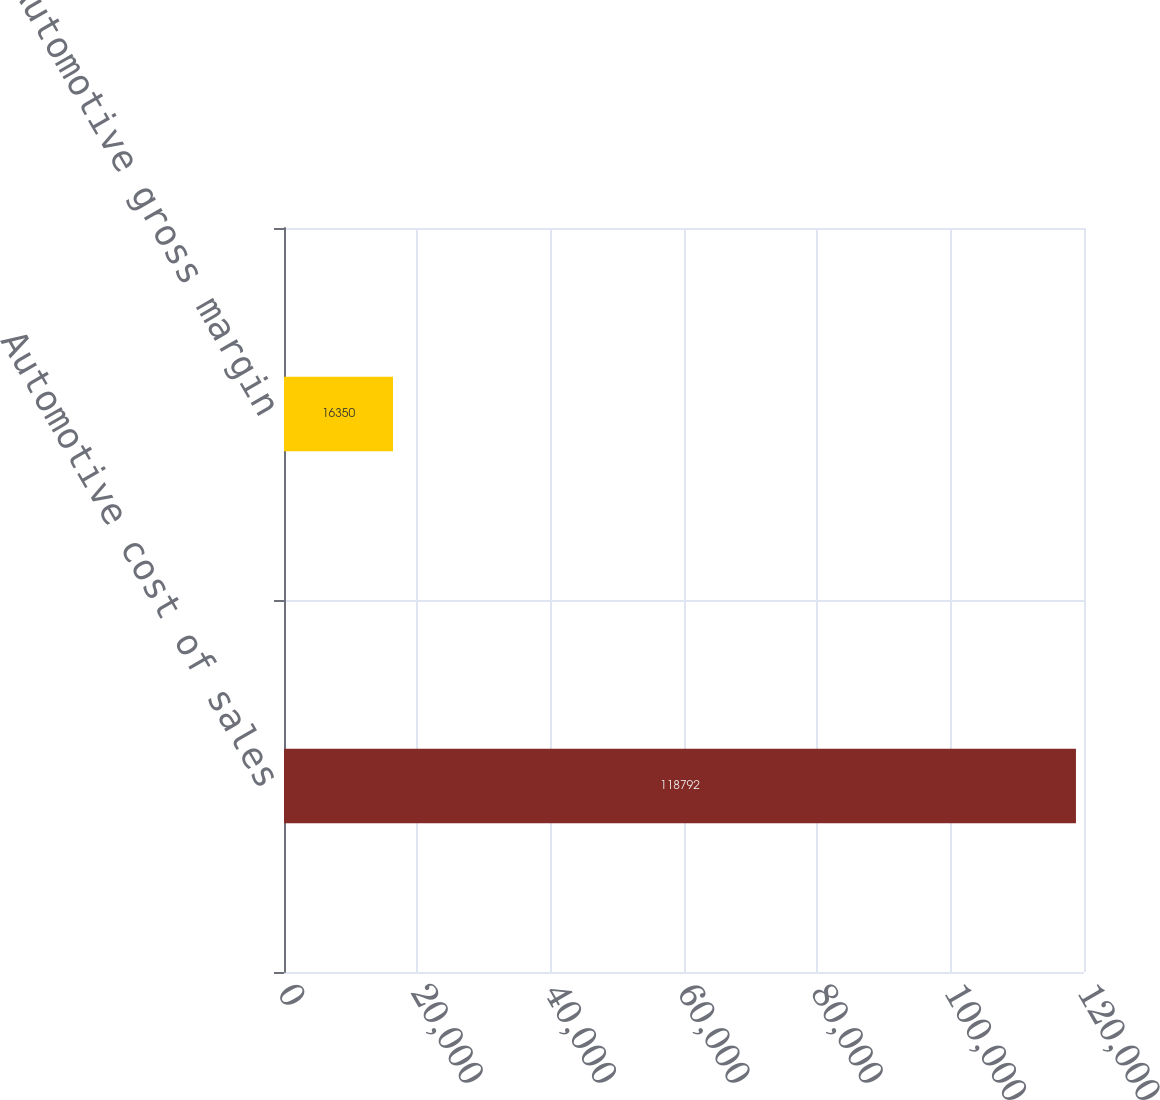Convert chart to OTSL. <chart><loc_0><loc_0><loc_500><loc_500><bar_chart><fcel>Automotive cost of sales<fcel>Automotive gross margin<nl><fcel>118792<fcel>16350<nl></chart> 